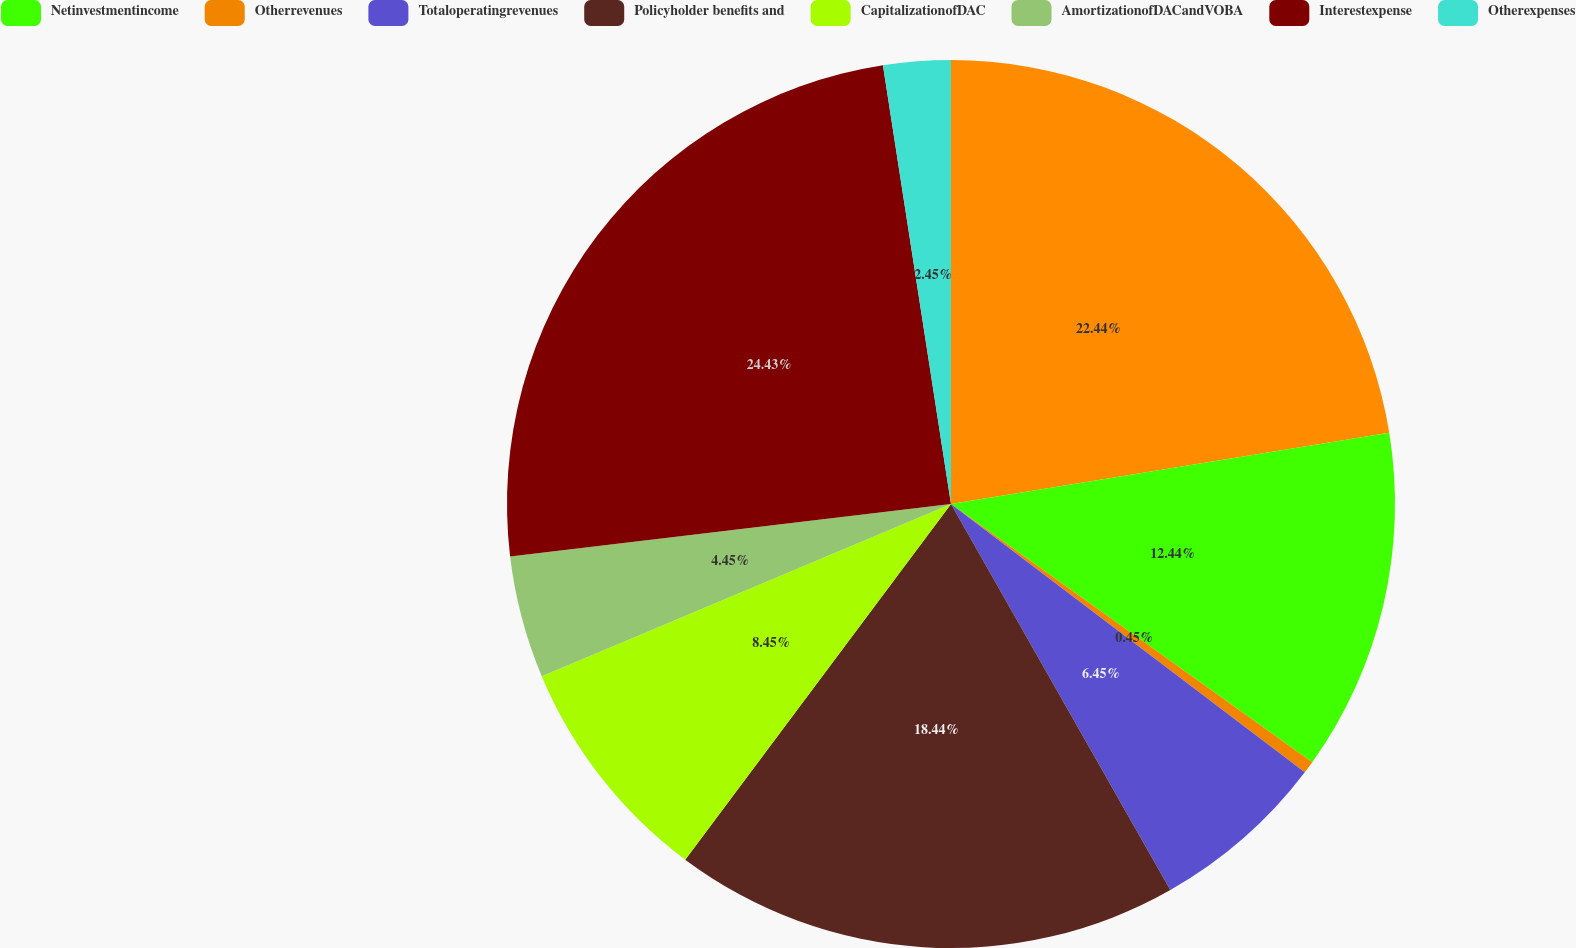Convert chart to OTSL. <chart><loc_0><loc_0><loc_500><loc_500><pie_chart><ecel><fcel>Netinvestmentincome<fcel>Otherrevenues<fcel>Totaloperatingrevenues<fcel>Policyholder benefits and<fcel>CapitalizationofDAC<fcel>AmortizationofDACandVOBA<fcel>Interestexpense<fcel>Otherexpenses<nl><fcel>22.44%<fcel>12.44%<fcel>0.45%<fcel>6.45%<fcel>18.44%<fcel>8.45%<fcel>4.45%<fcel>24.44%<fcel>2.45%<nl></chart> 